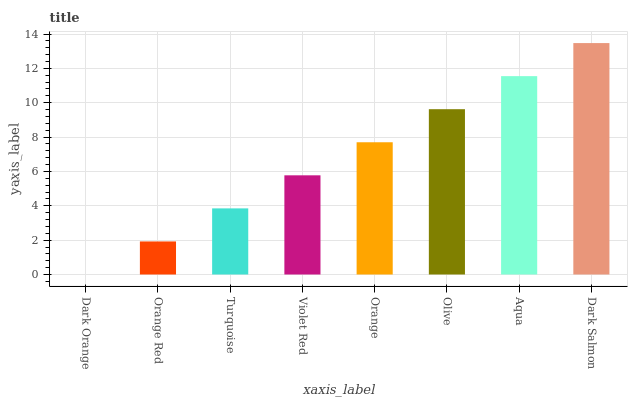Is Dark Orange the minimum?
Answer yes or no. Yes. Is Dark Salmon the maximum?
Answer yes or no. Yes. Is Orange Red the minimum?
Answer yes or no. No. Is Orange Red the maximum?
Answer yes or no. No. Is Orange Red greater than Dark Orange?
Answer yes or no. Yes. Is Dark Orange less than Orange Red?
Answer yes or no. Yes. Is Dark Orange greater than Orange Red?
Answer yes or no. No. Is Orange Red less than Dark Orange?
Answer yes or no. No. Is Orange the high median?
Answer yes or no. Yes. Is Violet Red the low median?
Answer yes or no. Yes. Is Violet Red the high median?
Answer yes or no. No. Is Olive the low median?
Answer yes or no. No. 